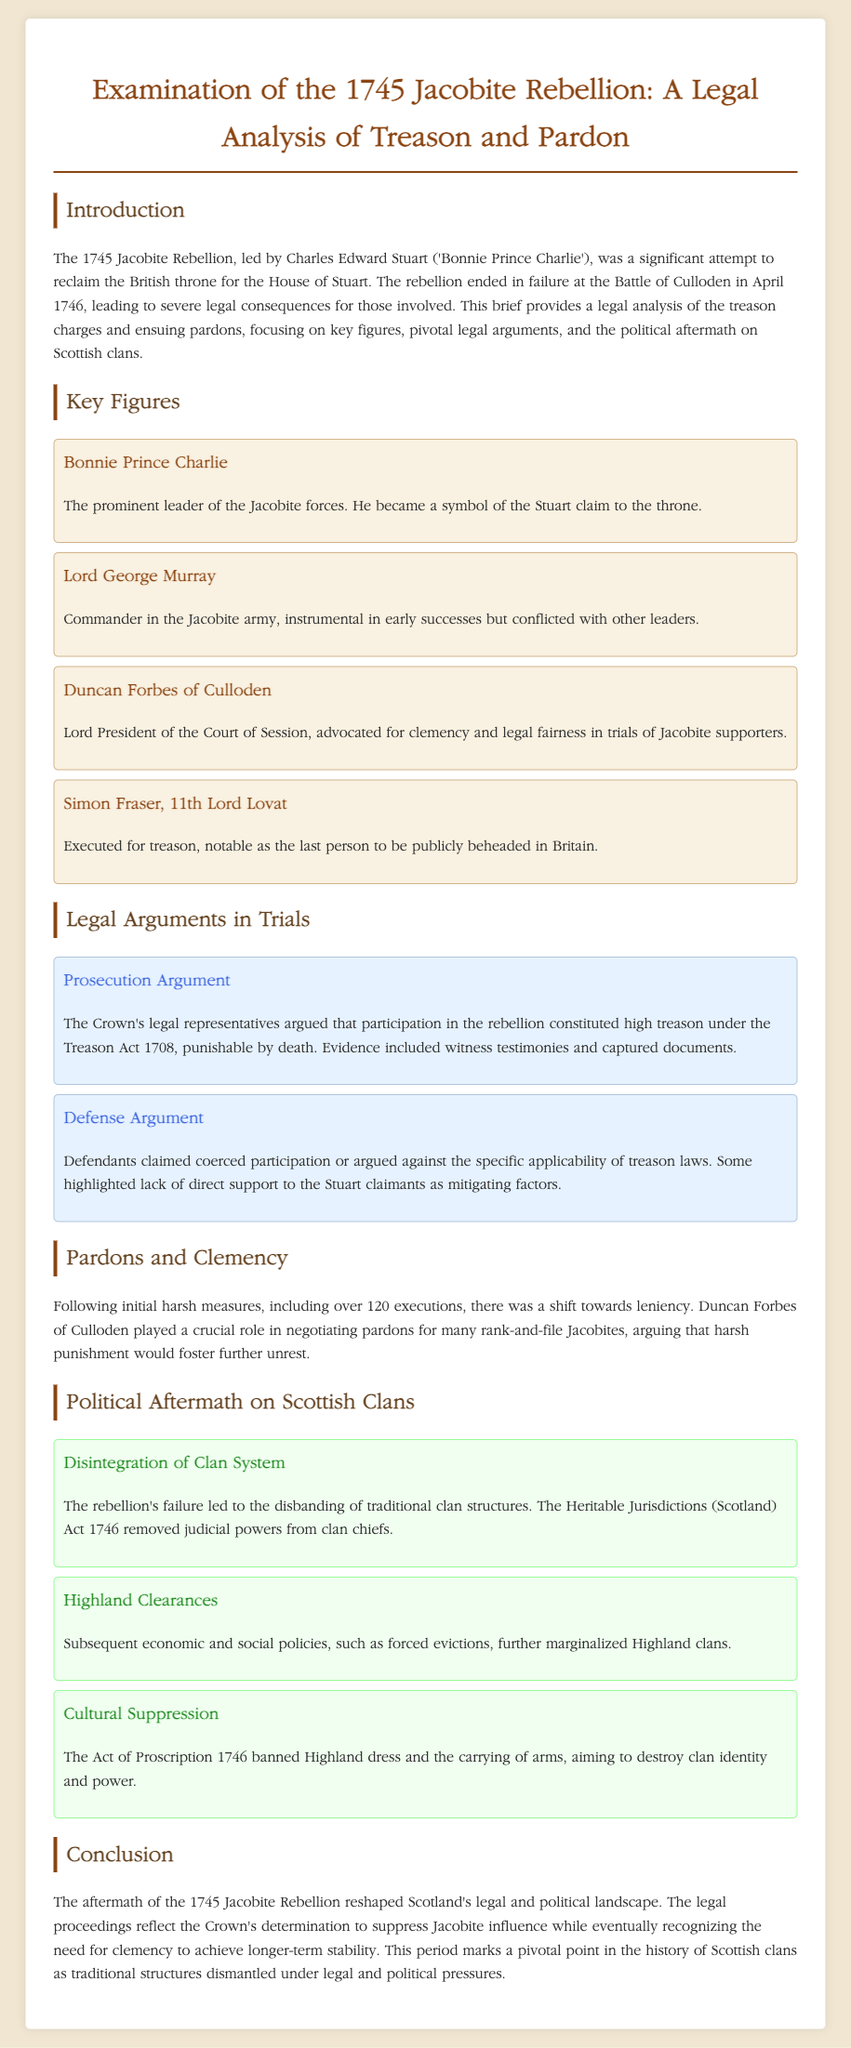what was the main goal of the 1745 Jacobite Rebellion? The goal was to reclaim the British throne for the House of Stuart.
Answer: reclaim the British throne who was the prominent leader of the Jacobite forces? The document identifies the leader as Charles Edward Stuart.
Answer: Charles Edward Stuart how many executions followed the Jacobite Rebellion? The document states that there were over 120 executions.
Answer: over 120 executions which legal act was cited in the prosecution of the Jacobite rebels? The prosecution cited the Treason Act 1708 in their arguments.
Answer: Treason Act 1708 who advocated for clemency in the trials? Duncan Forbes of Culloden advocated for clemency and legal fairness.
Answer: Duncan Forbes of Culloden what significant act removed judicial powers from clan chiefs? The Heritable Jurisdictions (Scotland) Act 1746 removed judicial powers.
Answer: Heritable Jurisdictions (Scotland) Act 1746 what was the fate of Simon Fraser, 11th Lord Lovat? Simon Fraser was executed for treason.
Answer: executed for treason what law banned Highland dress after the rebellion? The Act of Proscription 1746 banned Highland dress.
Answer: Act of Proscription 1746 what role did Duncan Forbes play after the rebellion? He played a crucial role in negotiating pardons for rank-and-file Jacobites.
Answer: negotiating pardons 